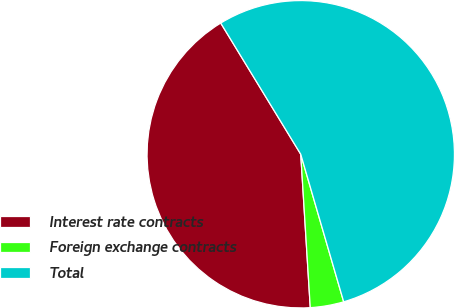Convert chart. <chart><loc_0><loc_0><loc_500><loc_500><pie_chart><fcel>Interest rate contracts<fcel>Foreign exchange contracts<fcel>Total<nl><fcel>42.27%<fcel>3.52%<fcel>54.21%<nl></chart> 